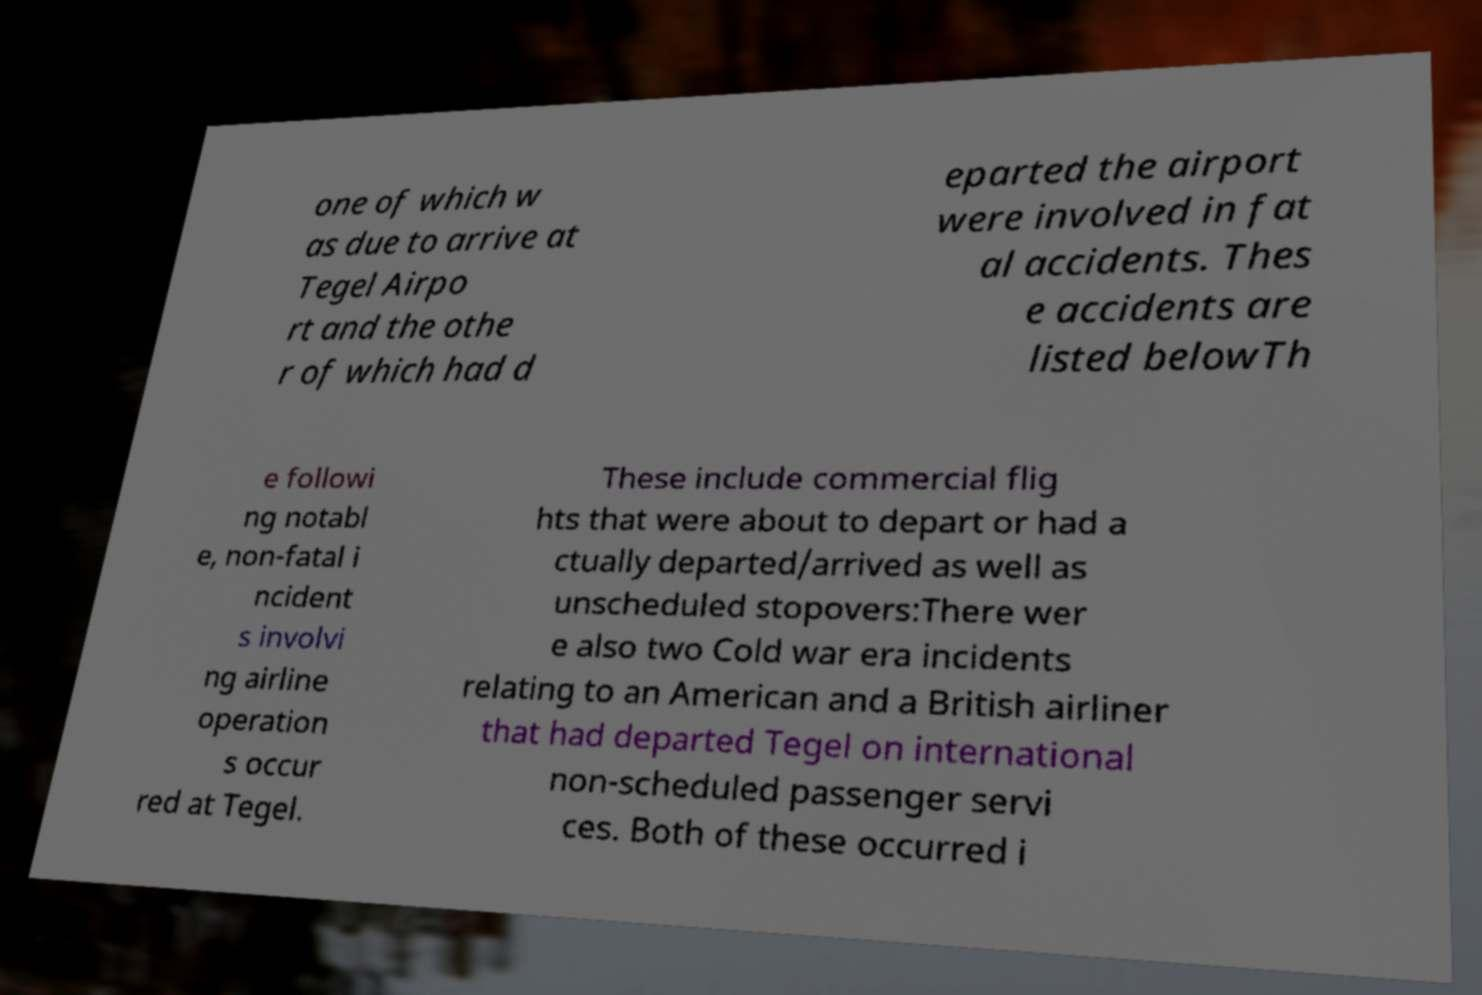Could you assist in decoding the text presented in this image and type it out clearly? one of which w as due to arrive at Tegel Airpo rt and the othe r of which had d eparted the airport were involved in fat al accidents. Thes e accidents are listed belowTh e followi ng notabl e, non-fatal i ncident s involvi ng airline operation s occur red at Tegel. These include commercial flig hts that were about to depart or had a ctually departed/arrived as well as unscheduled stopovers:There wer e also two Cold war era incidents relating to an American and a British airliner that had departed Tegel on international non-scheduled passenger servi ces. Both of these occurred i 